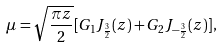<formula> <loc_0><loc_0><loc_500><loc_500>\mu = \sqrt { \frac { \pi z } { 2 } } [ G _ { 1 } J _ { \frac { 3 } { 2 } } ( z ) + G _ { 2 } J _ { - \frac { 3 } { 2 } } ( z ) ] ,</formula> 